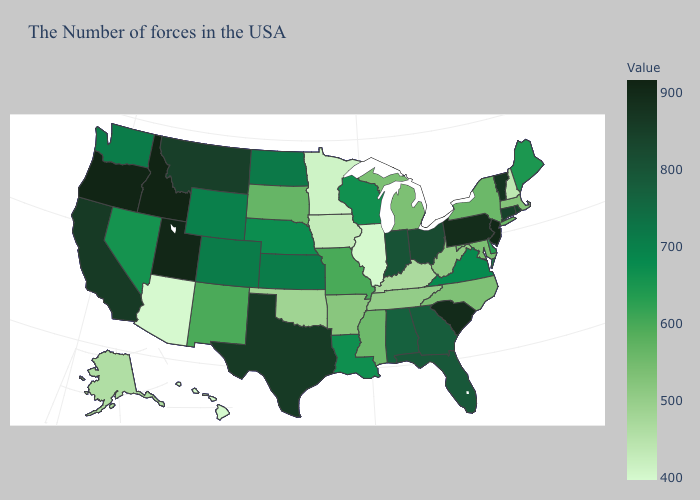Which states have the highest value in the USA?
Be succinct. Idaho. Does Arizona have the lowest value in the USA?
Short answer required. Yes. Among the states that border Iowa , does Nebraska have the lowest value?
Answer briefly. No. 